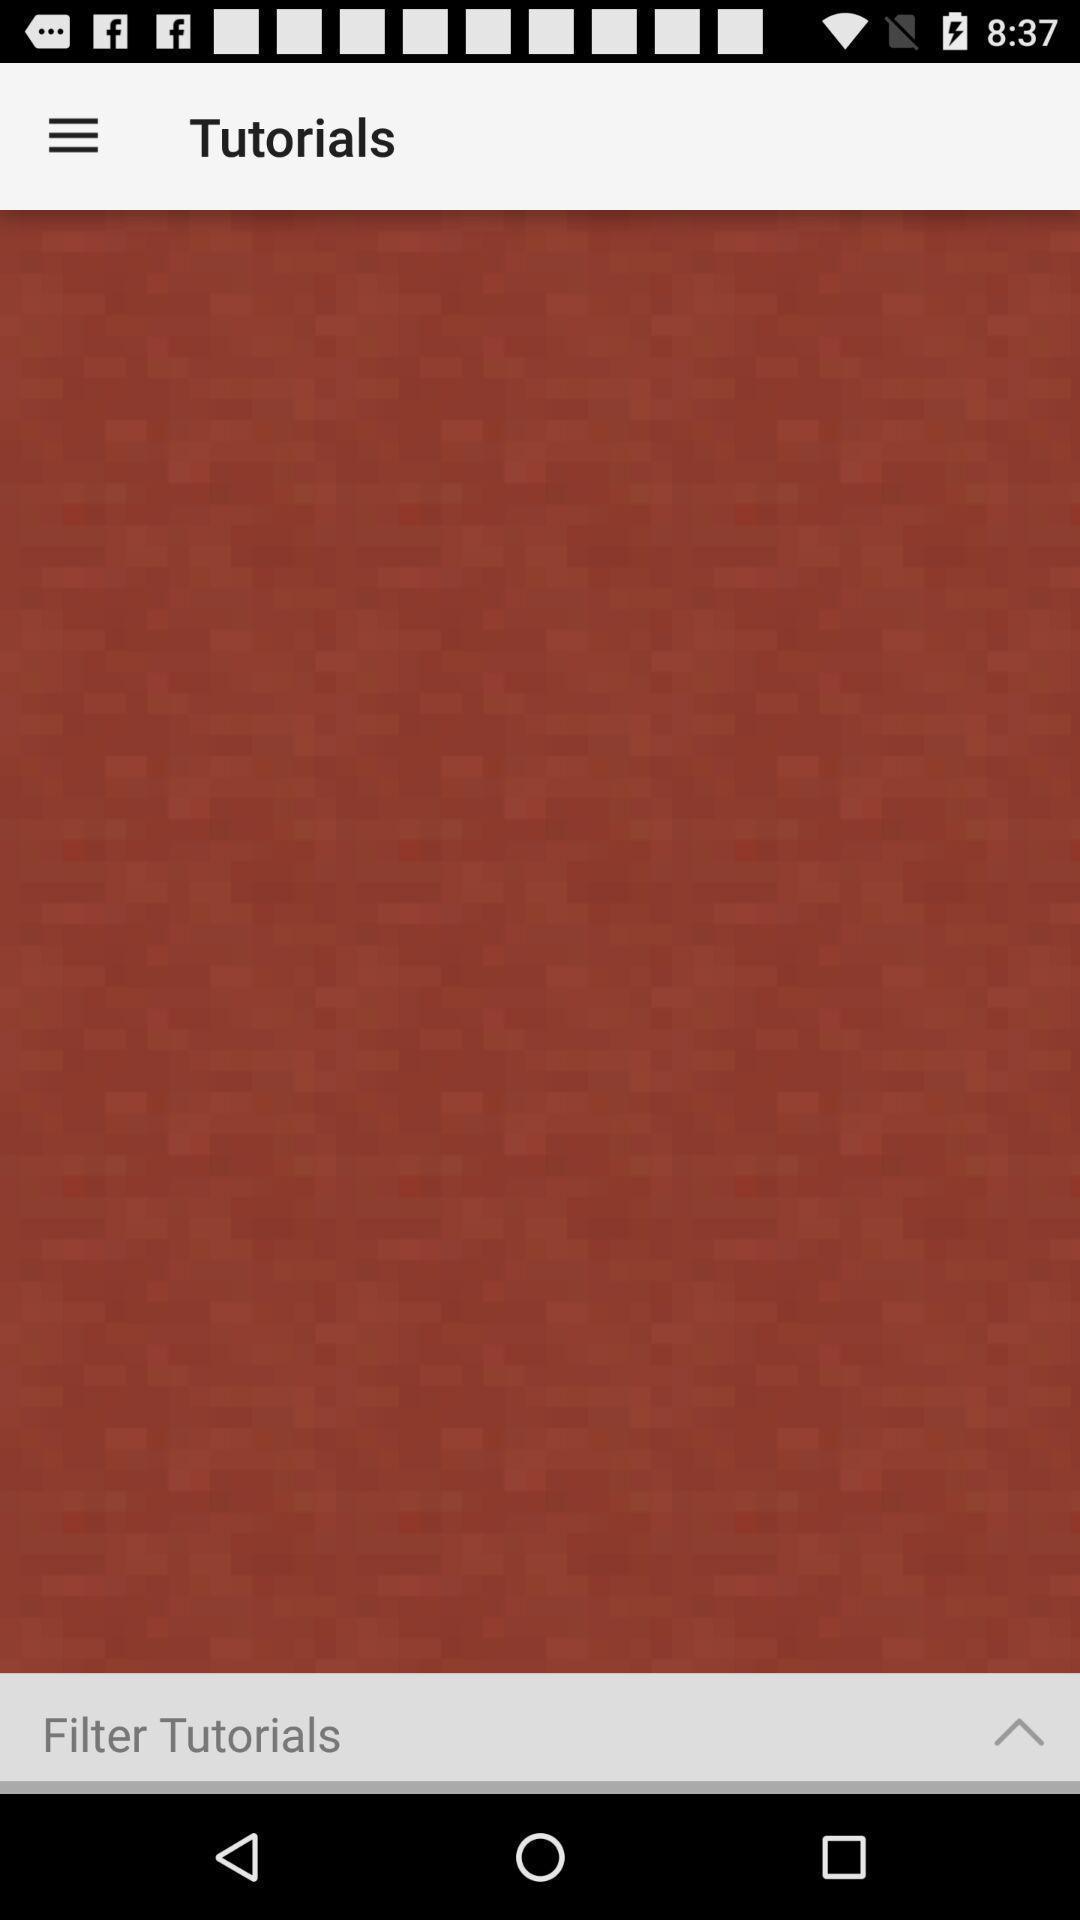Explain the elements present in this screenshot. Tutorials page is being displayed in the app. 